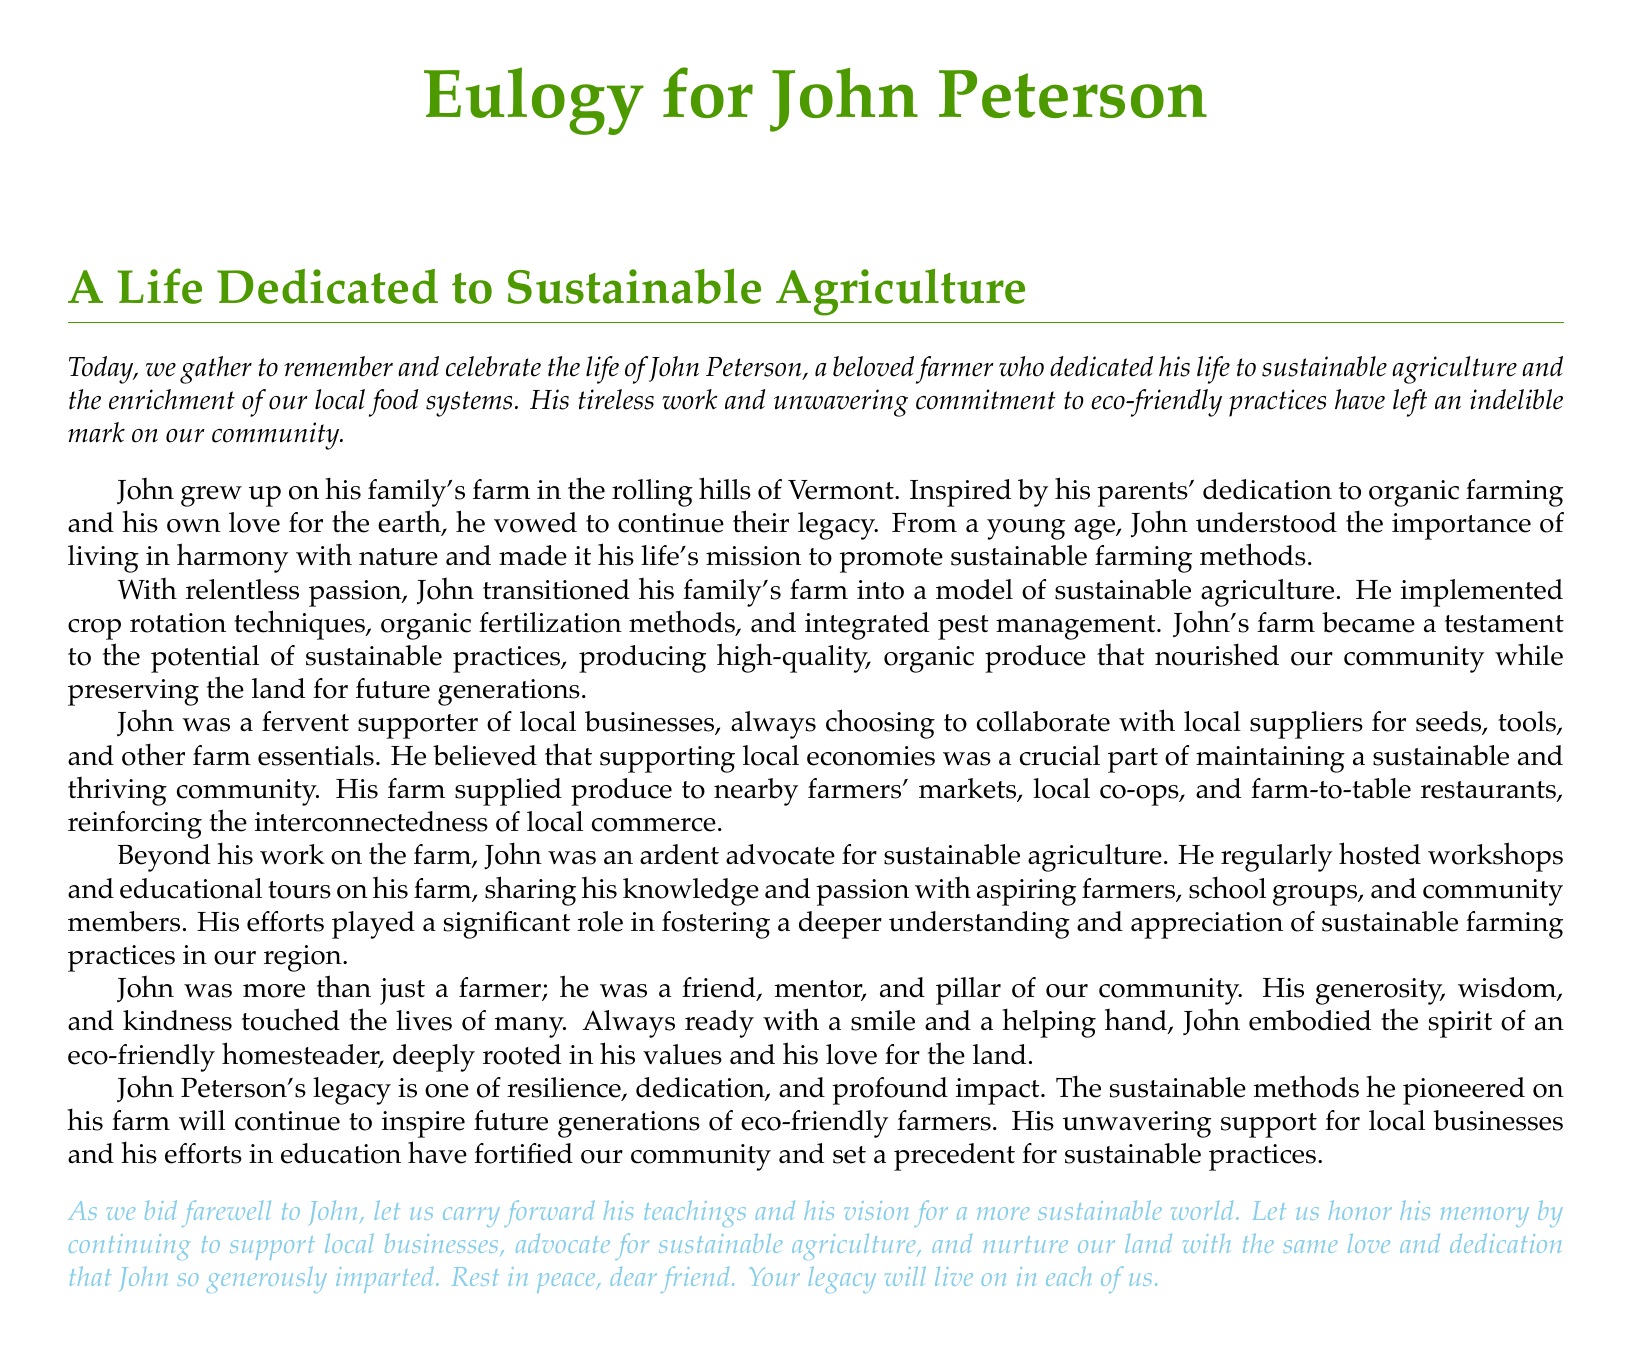What was John Peterson's profession? John Peterson was a beloved farmer dedicated to sustainable agriculture.
Answer: farmer What farming methods did John implement? John implemented crop rotation techniques, organic fertilization methods, and integrated pest management.
Answer: sustainable methods Where did John grow up? John grew up on his family's farm in the rolling hills of Vermont.
Answer: Vermont What type of produce did John’s farm supply? John’s farm supplied organic produce to nearby farmers' markets, local co-ops, and farm-to-table restaurants.
Answer: organic produce What community role did John play? John was a friend, mentor, and pillar of the community.
Answer: mentor Besides farming, what did John do to promote sustainable agriculture? John regularly hosted workshops and educational tours on his farm.
Answer: workshops What legacy did John leave behind? John's legacy is one of resilience, dedication, and profound impact on sustainable agriculture.
Answer: profound impact What was John's view on local businesses? John believed that supporting local economies was crucial for maintaining a sustainable community.
Answer: crucial What color is used for the document title? The document title is in the color earth green.
Answer: earth green 